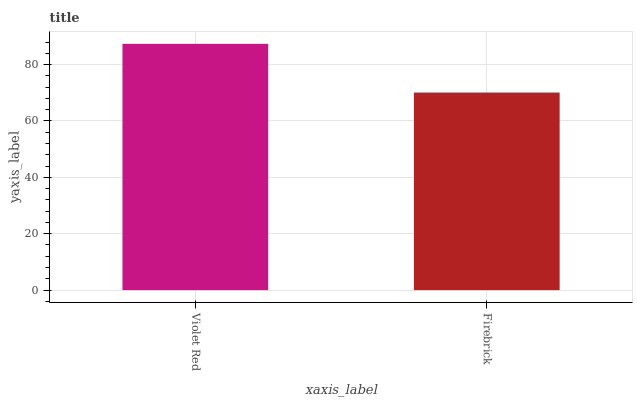Is Firebrick the minimum?
Answer yes or no. Yes. Is Violet Red the maximum?
Answer yes or no. Yes. Is Firebrick the maximum?
Answer yes or no. No. Is Violet Red greater than Firebrick?
Answer yes or no. Yes. Is Firebrick less than Violet Red?
Answer yes or no. Yes. Is Firebrick greater than Violet Red?
Answer yes or no. No. Is Violet Red less than Firebrick?
Answer yes or no. No. Is Violet Red the high median?
Answer yes or no. Yes. Is Firebrick the low median?
Answer yes or no. Yes. Is Firebrick the high median?
Answer yes or no. No. Is Violet Red the low median?
Answer yes or no. No. 